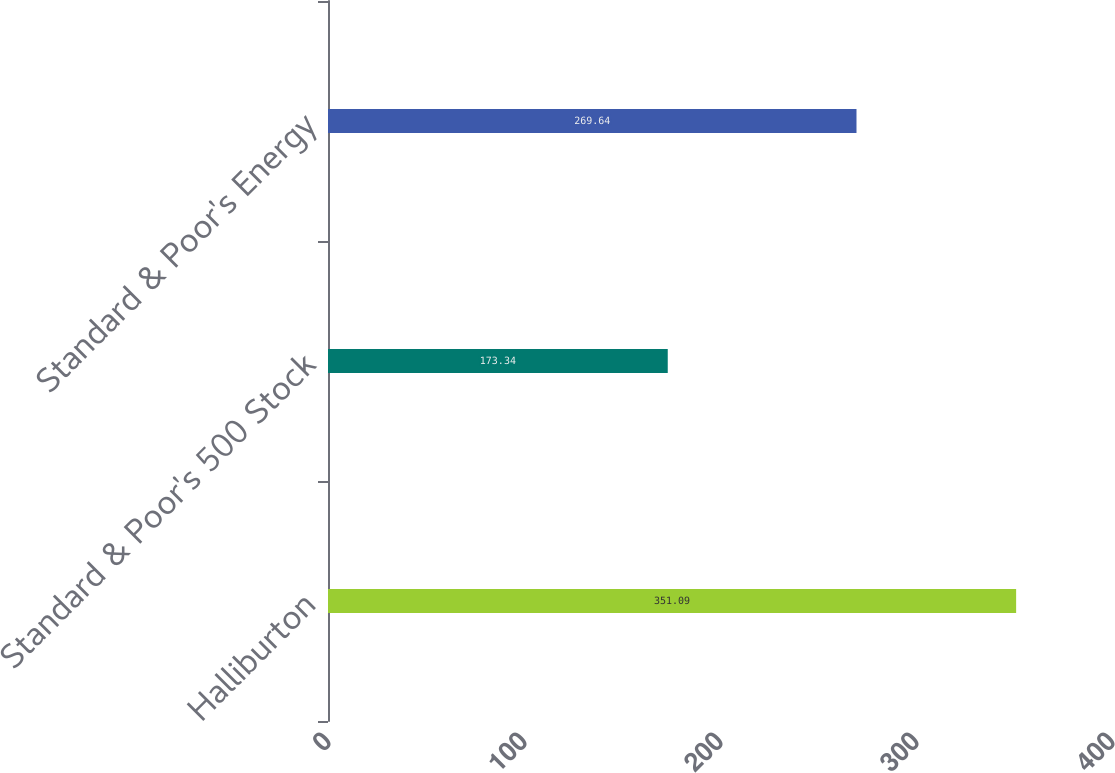Convert chart. <chart><loc_0><loc_0><loc_500><loc_500><bar_chart><fcel>Halliburton<fcel>Standard & Poor's 500 Stock<fcel>Standard & Poor's Energy<nl><fcel>351.09<fcel>173.34<fcel>269.64<nl></chart> 